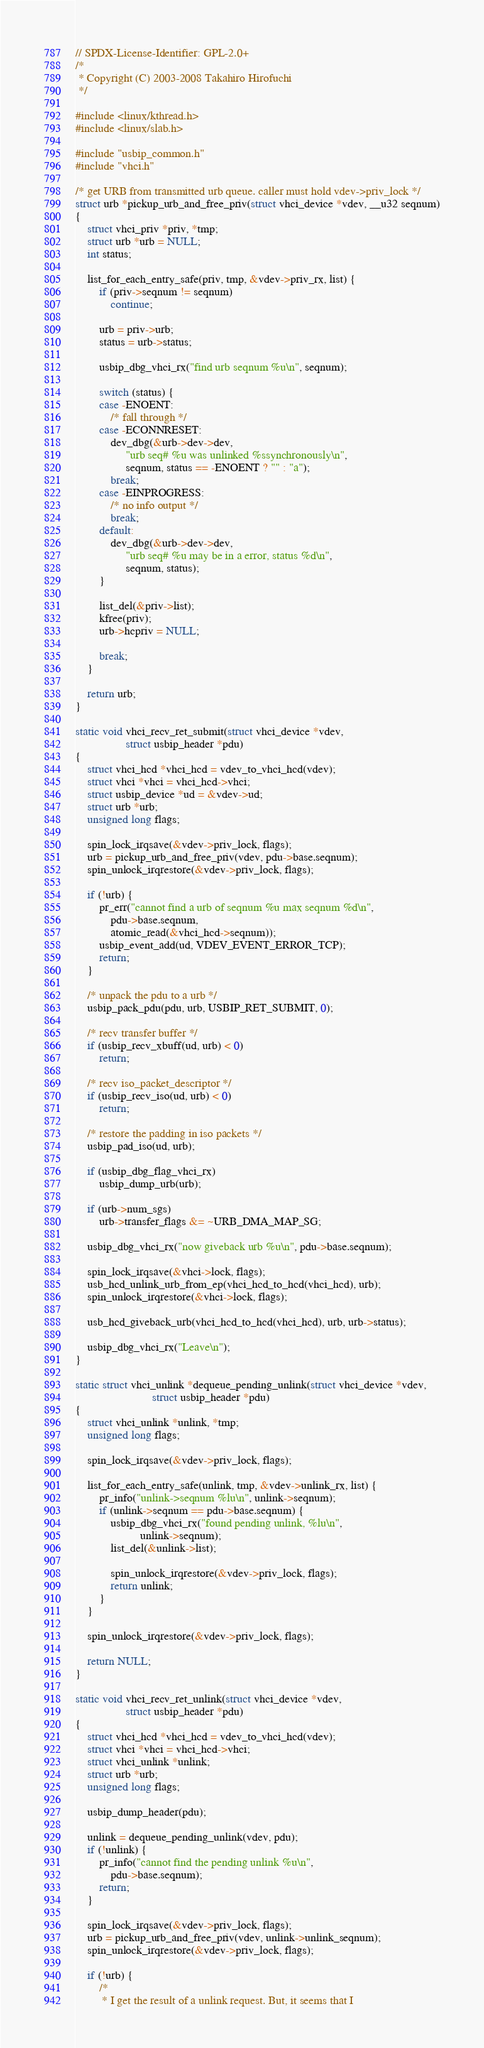Convert code to text. <code><loc_0><loc_0><loc_500><loc_500><_C_>// SPDX-License-Identifier: GPL-2.0+
/*
 * Copyright (C) 2003-2008 Takahiro Hirofuchi
 */

#include <linux/kthread.h>
#include <linux/slab.h>

#include "usbip_common.h"
#include "vhci.h"

/* get URB from transmitted urb queue. caller must hold vdev->priv_lock */
struct urb *pickup_urb_and_free_priv(struct vhci_device *vdev, __u32 seqnum)
{
	struct vhci_priv *priv, *tmp;
	struct urb *urb = NULL;
	int status;

	list_for_each_entry_safe(priv, tmp, &vdev->priv_rx, list) {
		if (priv->seqnum != seqnum)
			continue;

		urb = priv->urb;
		status = urb->status;

		usbip_dbg_vhci_rx("find urb seqnum %u\n", seqnum);

		switch (status) {
		case -ENOENT:
			/* fall through */
		case -ECONNRESET:
			dev_dbg(&urb->dev->dev,
				 "urb seq# %u was unlinked %ssynchronously\n",
				 seqnum, status == -ENOENT ? "" : "a");
			break;
		case -EINPROGRESS:
			/* no info output */
			break;
		default:
			dev_dbg(&urb->dev->dev,
				 "urb seq# %u may be in a error, status %d\n",
				 seqnum, status);
		}

		list_del(&priv->list);
		kfree(priv);
		urb->hcpriv = NULL;

		break;
	}

	return urb;
}

static void vhci_recv_ret_submit(struct vhci_device *vdev,
				 struct usbip_header *pdu)
{
	struct vhci_hcd *vhci_hcd = vdev_to_vhci_hcd(vdev);
	struct vhci *vhci = vhci_hcd->vhci;
	struct usbip_device *ud = &vdev->ud;
	struct urb *urb;
	unsigned long flags;

	spin_lock_irqsave(&vdev->priv_lock, flags);
	urb = pickup_urb_and_free_priv(vdev, pdu->base.seqnum);
	spin_unlock_irqrestore(&vdev->priv_lock, flags);

	if (!urb) {
		pr_err("cannot find a urb of seqnum %u max seqnum %d\n",
			pdu->base.seqnum,
			atomic_read(&vhci_hcd->seqnum));
		usbip_event_add(ud, VDEV_EVENT_ERROR_TCP);
		return;
	}

	/* unpack the pdu to a urb */
	usbip_pack_pdu(pdu, urb, USBIP_RET_SUBMIT, 0);

	/* recv transfer buffer */
	if (usbip_recv_xbuff(ud, urb) < 0)
		return;

	/* recv iso_packet_descriptor */
	if (usbip_recv_iso(ud, urb) < 0)
		return;

	/* restore the padding in iso packets */
	usbip_pad_iso(ud, urb);

	if (usbip_dbg_flag_vhci_rx)
		usbip_dump_urb(urb);

	if (urb->num_sgs)
		urb->transfer_flags &= ~URB_DMA_MAP_SG;

	usbip_dbg_vhci_rx("now giveback urb %u\n", pdu->base.seqnum);

	spin_lock_irqsave(&vhci->lock, flags);
	usb_hcd_unlink_urb_from_ep(vhci_hcd_to_hcd(vhci_hcd), urb);
	spin_unlock_irqrestore(&vhci->lock, flags);

	usb_hcd_giveback_urb(vhci_hcd_to_hcd(vhci_hcd), urb, urb->status);

	usbip_dbg_vhci_rx("Leave\n");
}

static struct vhci_unlink *dequeue_pending_unlink(struct vhci_device *vdev,
						  struct usbip_header *pdu)
{
	struct vhci_unlink *unlink, *tmp;
	unsigned long flags;

	spin_lock_irqsave(&vdev->priv_lock, flags);

	list_for_each_entry_safe(unlink, tmp, &vdev->unlink_rx, list) {
		pr_info("unlink->seqnum %lu\n", unlink->seqnum);
		if (unlink->seqnum == pdu->base.seqnum) {
			usbip_dbg_vhci_rx("found pending unlink, %lu\n",
					  unlink->seqnum);
			list_del(&unlink->list);

			spin_unlock_irqrestore(&vdev->priv_lock, flags);
			return unlink;
		}
	}

	spin_unlock_irqrestore(&vdev->priv_lock, flags);

	return NULL;
}

static void vhci_recv_ret_unlink(struct vhci_device *vdev,
				 struct usbip_header *pdu)
{
	struct vhci_hcd *vhci_hcd = vdev_to_vhci_hcd(vdev);
	struct vhci *vhci = vhci_hcd->vhci;
	struct vhci_unlink *unlink;
	struct urb *urb;
	unsigned long flags;

	usbip_dump_header(pdu);

	unlink = dequeue_pending_unlink(vdev, pdu);
	if (!unlink) {
		pr_info("cannot find the pending unlink %u\n",
			pdu->base.seqnum);
		return;
	}

	spin_lock_irqsave(&vdev->priv_lock, flags);
	urb = pickup_urb_and_free_priv(vdev, unlink->unlink_seqnum);
	spin_unlock_irqrestore(&vdev->priv_lock, flags);

	if (!urb) {
		/*
		 * I get the result of a unlink request. But, it seems that I</code> 